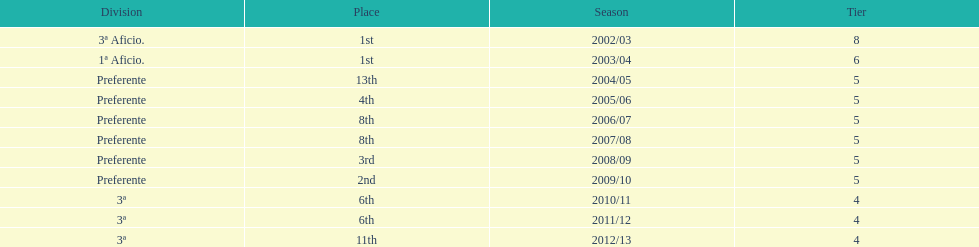How long did the team stay in first place? 2 years. 